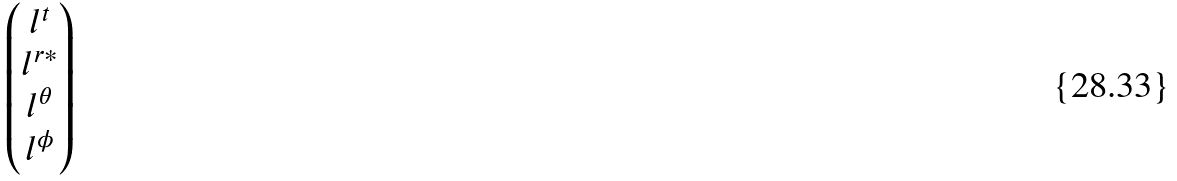<formula> <loc_0><loc_0><loc_500><loc_500>\begin{pmatrix} l ^ { t } \\ l ^ { r * } \\ l ^ { \theta } \\ l ^ { \phi } \end{pmatrix}</formula> 